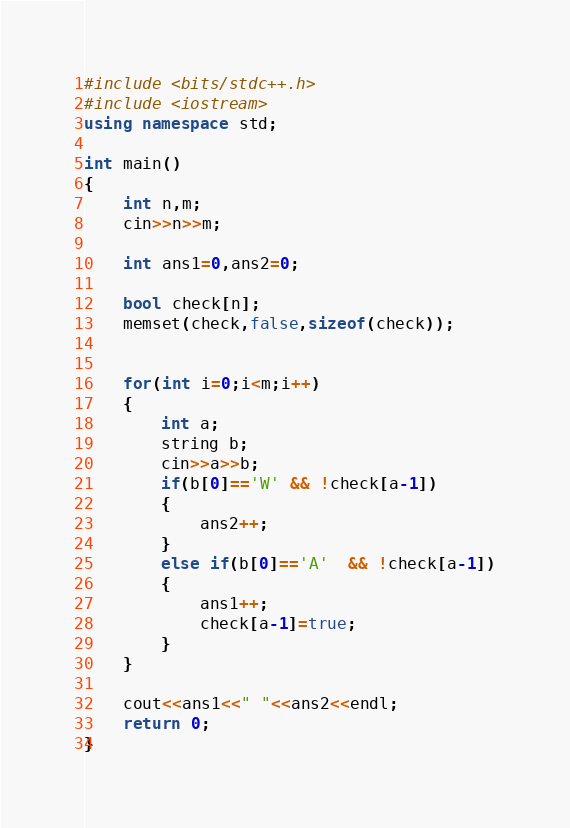Convert code to text. <code><loc_0><loc_0><loc_500><loc_500><_C++_>#include <bits/stdc++.h>
#include <iostream>
using namespace std;

int main()
{
	int n,m;
    cin>>n>>m;
    
    int ans1=0,ans2=0;
    
    bool check[n];
    memset(check,false,sizeof(check));
    
    
    for(int i=0;i<m;i++)
    {
    	int a;
        string b;
        cin>>a>>b;
        if(b[0]=='W' && !check[a-1])
        {
            ans2++;
        }
        else if(b[0]=='A'  && !check[a-1])
        {
            ans1++;
            check[a-1]=true;
        }
    }
    
    cout<<ans1<<" "<<ans2<<endl;
	return 0;
}</code> 